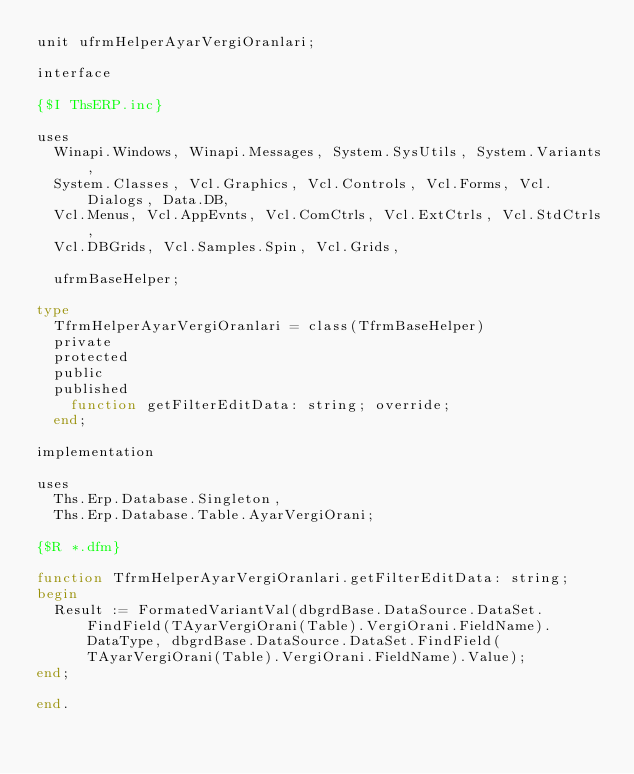Convert code to text. <code><loc_0><loc_0><loc_500><loc_500><_Pascal_>unit ufrmHelperAyarVergiOranlari;

interface

{$I ThsERP.inc}

uses
  Winapi.Windows, Winapi.Messages, System.SysUtils, System.Variants,
  System.Classes, Vcl.Graphics, Vcl.Controls, Vcl.Forms, Vcl.Dialogs, Data.DB,
  Vcl.Menus, Vcl.AppEvnts, Vcl.ComCtrls, Vcl.ExtCtrls, Vcl.StdCtrls,
  Vcl.DBGrids, Vcl.Samples.Spin, Vcl.Grids,

  ufrmBaseHelper;

type
  TfrmHelperAyarVergiOranlari = class(TfrmBaseHelper)
  private
  protected
  public
  published
    function getFilterEditData: string; override;
  end;

implementation

uses
  Ths.Erp.Database.Singleton,
  Ths.Erp.Database.Table.AyarVergiOrani;

{$R *.dfm}

function TfrmHelperAyarVergiOranlari.getFilterEditData: string;
begin
  Result := FormatedVariantVal(dbgrdBase.DataSource.DataSet.FindField(TAyarVergiOrani(Table).VergiOrani.FieldName).DataType, dbgrdBase.DataSource.DataSet.FindField(TAyarVergiOrani(Table).VergiOrani.FieldName).Value);
end;

end.
</code> 